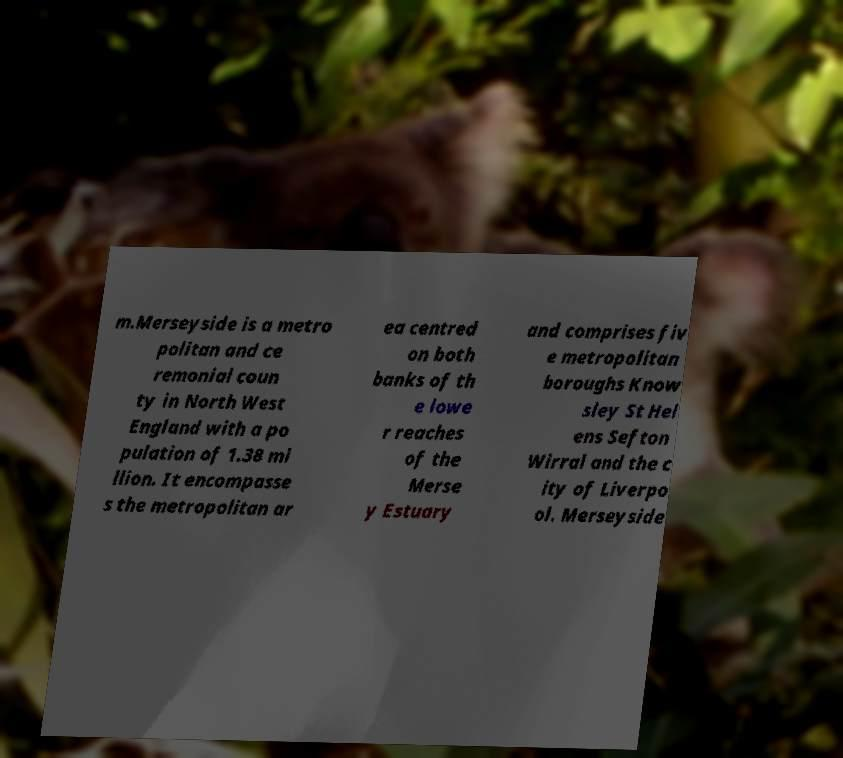Please read and relay the text visible in this image. What does it say? m.Merseyside is a metro politan and ce remonial coun ty in North West England with a po pulation of 1.38 mi llion. It encompasse s the metropolitan ar ea centred on both banks of th e lowe r reaches of the Merse y Estuary and comprises fiv e metropolitan boroughs Know sley St Hel ens Sefton Wirral and the c ity of Liverpo ol. Merseyside 